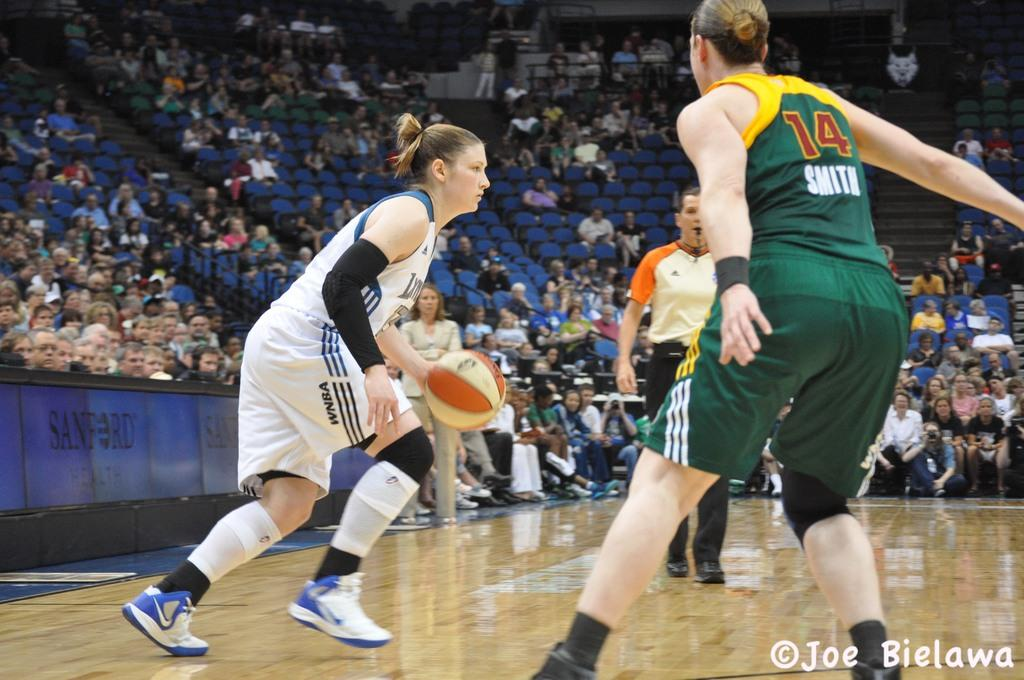What are the two persons in the image doing? The two persons in the image are playing basketball. What is the role of the person with a whistle in the image? The person with a whistle is a referee in the image. What is the referee using to signal or communicate during the game? The referee has a whistle in their mouth. What can be seen in the background of the image? There are many people sitting on chairs in the background. What type of cord is connected to the minister's microphone in the image? There is no minister or microphone present in the image; it features two persons playing basketball and a referee. 